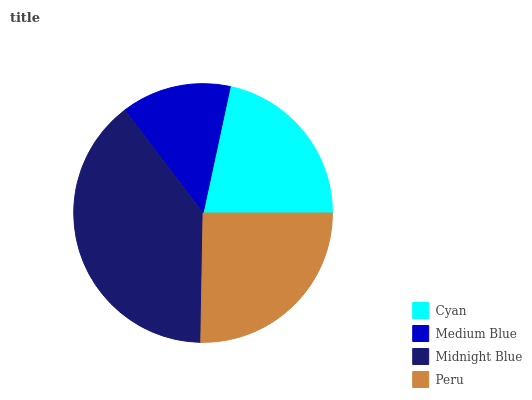Is Medium Blue the minimum?
Answer yes or no. Yes. Is Midnight Blue the maximum?
Answer yes or no. Yes. Is Midnight Blue the minimum?
Answer yes or no. No. Is Medium Blue the maximum?
Answer yes or no. No. Is Midnight Blue greater than Medium Blue?
Answer yes or no. Yes. Is Medium Blue less than Midnight Blue?
Answer yes or no. Yes. Is Medium Blue greater than Midnight Blue?
Answer yes or no. No. Is Midnight Blue less than Medium Blue?
Answer yes or no. No. Is Peru the high median?
Answer yes or no. Yes. Is Cyan the low median?
Answer yes or no. Yes. Is Medium Blue the high median?
Answer yes or no. No. Is Midnight Blue the low median?
Answer yes or no. No. 